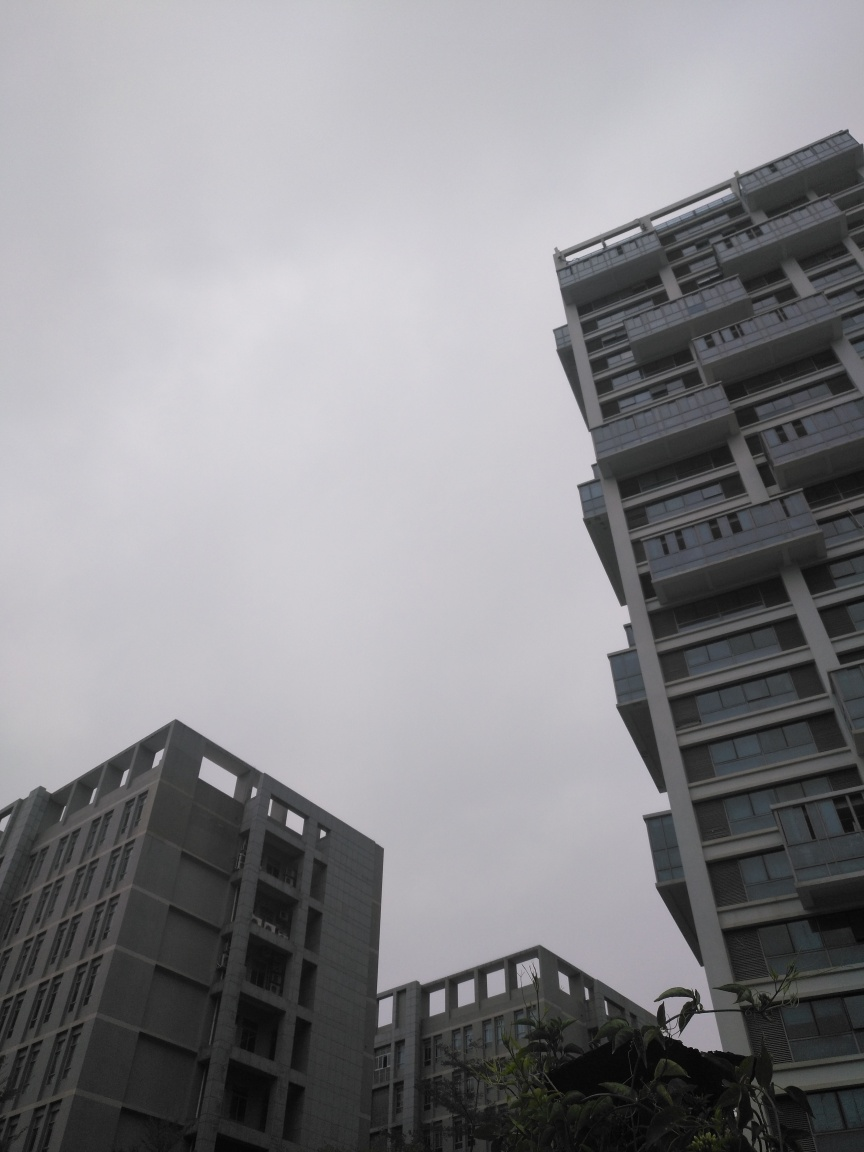Explore the quality factors of the image and offer an evaluation based on your insights. The image shows a clear outline of modern skyscrapers, suggesting a well-maintained focus. The composition skillfully captures the juxtaposition of multiple buildings and the expansive, overcast sky, which adds a dramatic touch to the scene. However, the image appears slightly underexposed which affects the visibility of finer details and gives the photo a somewhat gloomy feel. Adjusting the exposure or editing to brighten the image could enhance its appeal. Additionally, enhancing the contrast might help to delineate the buildings more distinctly against the cloudy sky. 